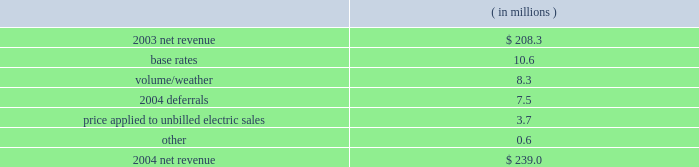Entergy new orleans , inc .
Management's financial discussion and analysis results of operations net income ( loss ) 2004 compared to 2003 net income increased $ 20.2 million primarily due to higher net revenue .
2003 compared to 2002 entergy new orleans had net income of $ 7.9 million in 2003 compared to a net loss in 2002 .
The increase was due to higher net revenue and lower interest expense , partially offset by higher other operation and maintenance expenses and depreciation and amortization expenses .
Net revenue 2004 compared to 2003 net revenue , which is entergy new orleans' measure of gross margin , consists of operating revenues net of : 1 ) fuel , fuel-related , and purchased power expenses and 2 ) other regulatory credits .
Following is an analysis of the change in net revenue comparing 2004 to 2003. .
The increase in base rates was effective june 2003 .
The rate increase is discussed in note 2 to the domestic utility companies and system energy financial statements .
The volume/weather variance is primarily due to increased billed electric usage of 162 gwh in the industrial service sector .
The increase was partially offset by milder weather in the residential and commercial sectors .
The 2004 deferrals variance is due to the deferral of voluntary severance plan and fossil plant maintenance expenses in accordance with a stipulation approved by the city council in august 2004 .
The stipulation allows for the recovery of these costs through amortization of a regulatory asset .
The voluntary severance plan and fossil plant maintenance expenses are being amortized over a five-year period that became effective january 2004 and january 2003 , respectively .
The formula rate plan is discussed in note 2 to the domestic utility companies and system energy financial statements .
The price applied to unbilled electric sales variance is due to an increase in the fuel price applied to unbilled sales. .
What is the growth rate in net revenue for entergy new orleans , inc . in 2004? 
Computations: ((239.0 - 208.3) / 208.3)
Answer: 0.14738. 